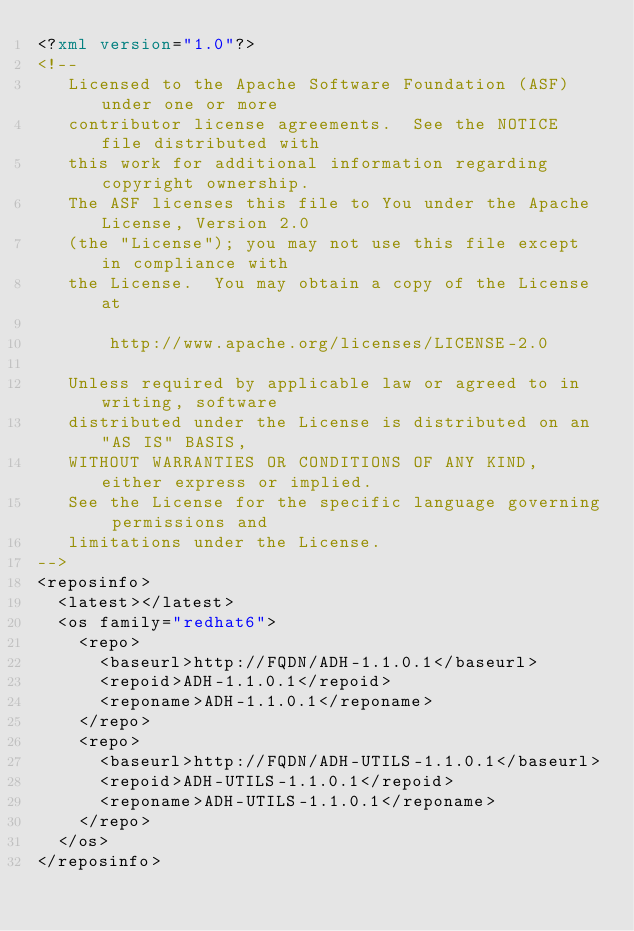Convert code to text. <code><loc_0><loc_0><loc_500><loc_500><_XML_><?xml version="1.0"?>
<!--
   Licensed to the Apache Software Foundation (ASF) under one or more
   contributor license agreements.  See the NOTICE file distributed with
   this work for additional information regarding copyright ownership.
   The ASF licenses this file to You under the Apache License, Version 2.0
   (the "License"); you may not use this file except in compliance with
   the License.  You may obtain a copy of the License at

       http://www.apache.org/licenses/LICENSE-2.0

   Unless required by applicable law or agreed to in writing, software
   distributed under the License is distributed on an "AS IS" BASIS,
   WITHOUT WARRANTIES OR CONDITIONS OF ANY KIND, either express or implied.
   See the License for the specific language governing permissions and
   limitations under the License.
-->
<reposinfo>
  <latest></latest>
  <os family="redhat6">
    <repo>
      <baseurl>http://FQDN/ADH-1.1.0.1</baseurl>
      <repoid>ADH-1.1.0.1</repoid>
      <reponame>ADH-1.1.0.1</reponame>
    </repo>
    <repo>
      <baseurl>http://FQDN/ADH-UTILS-1.1.0.1</baseurl>
      <repoid>ADH-UTILS-1.1.0.1</repoid>
      <reponame>ADH-UTILS-1.1.0.1</reponame>
    </repo>
  </os>
</reposinfo>
</code> 